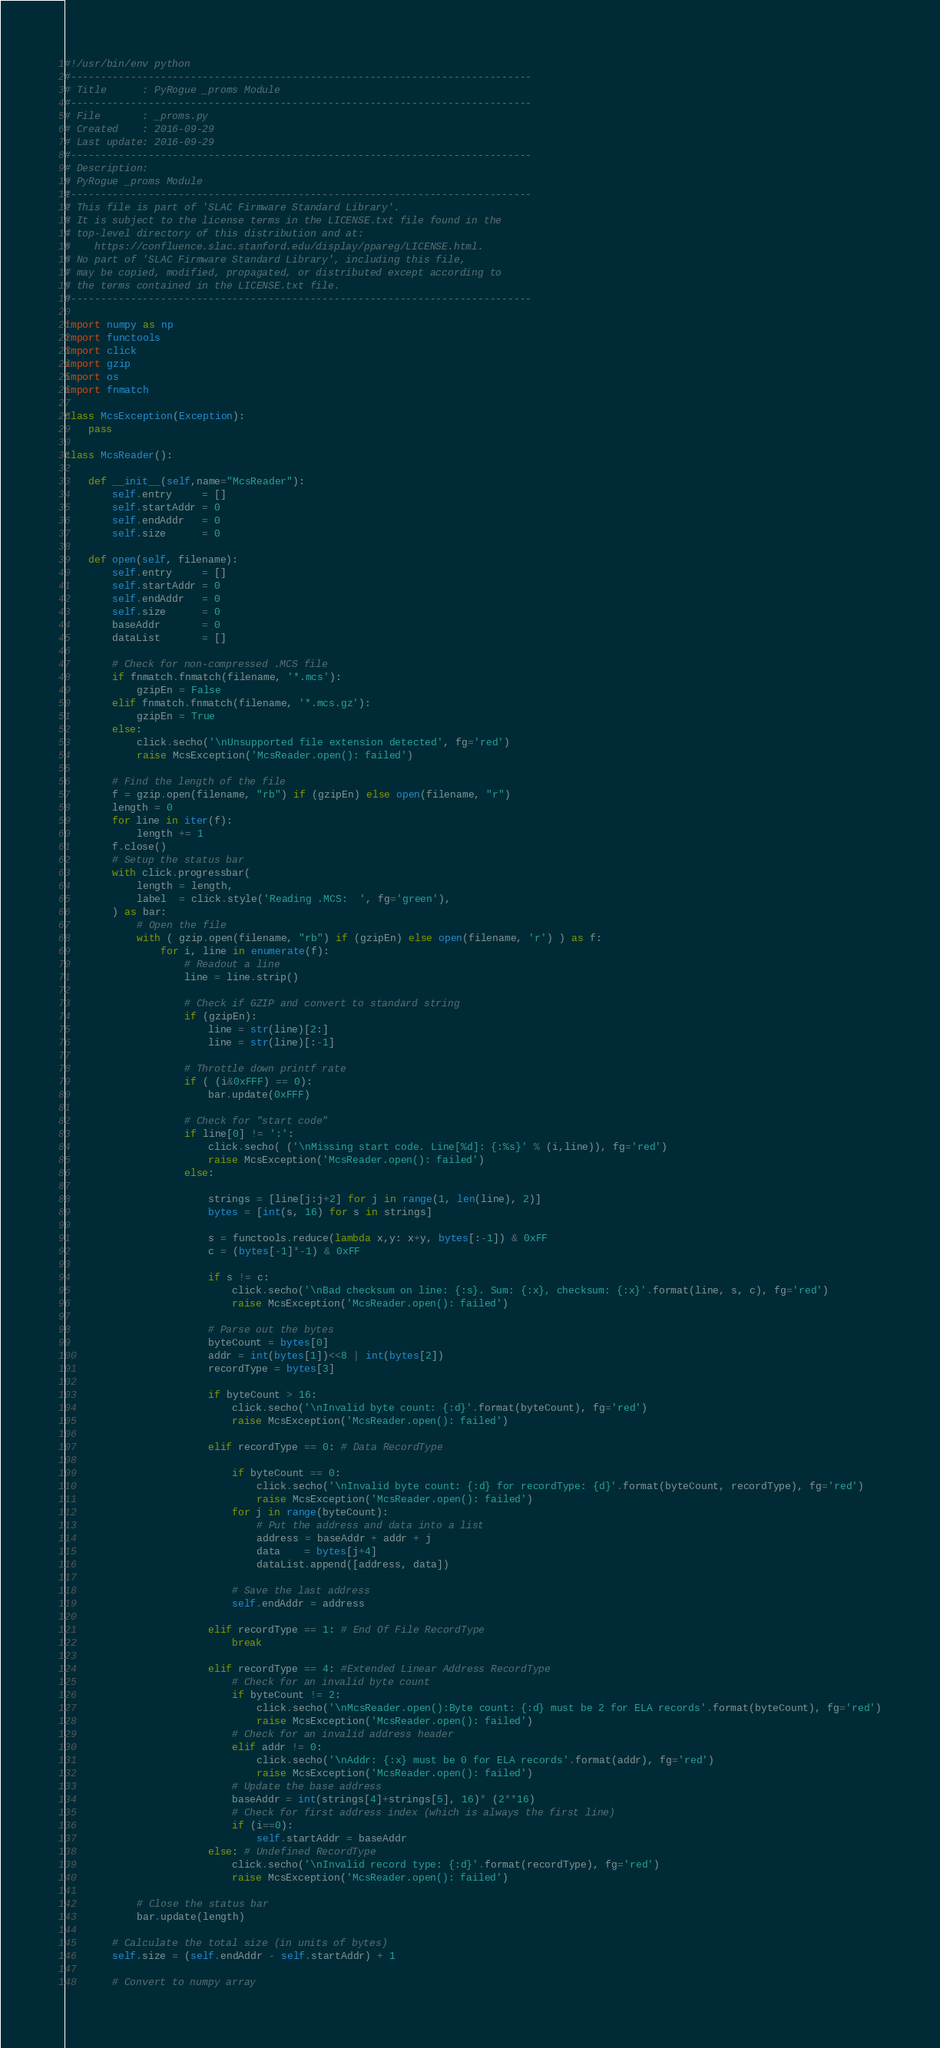<code> <loc_0><loc_0><loc_500><loc_500><_Python_>#!/usr/bin/env python
#-----------------------------------------------------------------------------
# Title      : PyRogue _proms Module
#-----------------------------------------------------------------------------
# File       : _proms.py
# Created    : 2016-09-29
# Last update: 2016-09-29
#-----------------------------------------------------------------------------
# Description:
# PyRogue _proms Module
#-----------------------------------------------------------------------------
# This file is part of 'SLAC Firmware Standard Library'.
# It is subject to the license terms in the LICENSE.txt file found in the 
# top-level directory of this distribution and at: 
#    https://confluence.slac.stanford.edu/display/ppareg/LICENSE.html. 
# No part of 'SLAC Firmware Standard Library', including this file, 
# may be copied, modified, propagated, or distributed except according to 
# the terms contained in the LICENSE.txt file.
#-----------------------------------------------------------------------------

import numpy as np
import functools
import click 
import gzip
import os
import fnmatch

class McsException(Exception):
    pass

class McsReader():

    def __init__(self,name="McsReader"):
        self.entry     = []
        self.startAddr = 0
        self.endAddr   = 0
        self.size      = 0
        
    def open(self, filename):   
        self.entry     = []
        self.startAddr = 0
        self.endAddr   = 0
        self.size      = 0
        baseAddr       = 0
        dataList       = []

        # Check for non-compressed .MCS file
        if fnmatch.fnmatch(filename, '*.mcs'):
            gzipEn = False
        elif fnmatch.fnmatch(filename, '*.mcs.gz'):
            gzipEn = True
        else:
            click.secho('\nUnsupported file extension detected', fg='red')
            raise McsException('McsReader.open(): failed')  
            
        # Find the length of the file
        f = gzip.open(filename, "rb") if (gzipEn) else open(filename, "r")
        length = 0
        for line in iter(f):
            length += 1
        f.close()  
        # Setup the status bar
        with click.progressbar(
            length = length,
            label  = click.style('Reading .MCS:  ', fg='green'),
        ) as bar:            
            # Open the file
            with ( gzip.open(filename, "rb") if (gzipEn) else open(filename, 'r') ) as f:            
                for i, line in enumerate(f):
                    # Readout a line
                    line = line.strip()
                    
                    # Check if GZIP and convert to standard string
                    if (gzipEn):
                        line = str(line)[2:]
                        line = str(line)[:-1]
                    
                    # Throttle down printf rate
                    if ( (i&0xFFF) == 0):
                        bar.update(0xFFF)                      
                        
                    # Check for "start code"
                    if line[0] != ':':
                        click.secho( ('\nMissing start code. Line[%d]: {:%s}' % (i,line)), fg='red')
                        raise McsException('McsReader.open(): failed')                         
                    else:
                    
                        strings = [line[j:j+2] for j in range(1, len(line), 2)]
                        bytes = [int(s, 16) for s in strings]

                        s = functools.reduce(lambda x,y: x+y, bytes[:-1]) & 0xFF
                        c = (bytes[-1]*-1) & 0xFF
                        
                        if s != c:                            
                            click.secho('\nBad checksum on line: {:s}. Sum: {:x}, checksum: {:x}'.format(line, s, c), fg='red')
                            raise McsException('McsReader.open(): failed') 

                        # Parse out the bytes
                        byteCount = bytes[0]
                        addr = int(bytes[1])<<8 | int(bytes[2])
                        recordType = bytes[3]
                       
                        if byteCount > 16:
                            click.secho('\nInvalid byte count: {:d}'.format(byteCount), fg='red')
                            raise McsException('McsReader.open(): failed') 

                        elif recordType == 0: # Data RecordType           
                            
                            if byteCount == 0:
                                click.secho('\nInvalid byte count: {:d} for recordType: {d}'.format(byteCount, recordType), fg='red')
                                raise McsException('McsReader.open(): failed') 
                            for j in range(byteCount):
                                # Put the address and data into a list
                                address = baseAddr + addr + j
                                data    = bytes[j+4]
                                dataList.append([address, data])
                            
                            # Save the last address
                            self.endAddr = address
                            
                        elif recordType == 1: # End Of File RecordType 
                            break

                        elif recordType == 4: #Extended Linear Address RecordType
                            # Check for an invalid byte count
                            if byteCount != 2:
                                click.secho('\nMcsReader.open():Byte count: {:d} must be 2 for ELA records'.format(byteCount), fg='red')
                                raise McsException('McsReader.open(): failed')  
                            # Check for an invalid address header
                            elif addr != 0:
                                click.secho('\nAddr: {:x} must be 0 for ELA records'.format(addr), fg='red')
                                raise McsException('McsReader.open(): failed')  
                            # Update the base address 
                            baseAddr = int(strings[4]+strings[5], 16)* (2**16)
                            # Check for first address index (which is always the first line)
                            if (i==0):
                                self.startAddr = baseAddr
                        else: # Undefined RecordType
                            click.secho('\nInvalid record type: {:d}'.format(recordType), fg='red')
                            raise McsException('McsReader.open(): failed')    
                            
            # Close the status bar
            bar.update(length)          
            
        # Calculate the total size (in units of bytes)                
        self.size = (self.endAddr - self.startAddr) + 1
        
        # Convert to numpy array</code> 